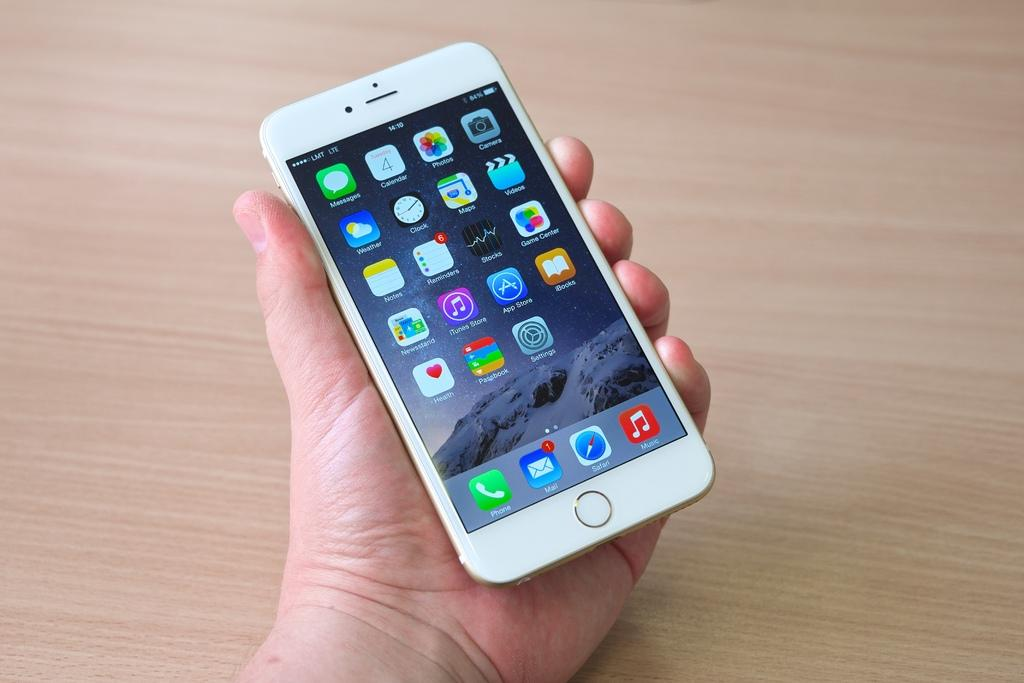<image>
Offer a succinct explanation of the picture presented. A white phone with applications on the screen including "Music", "Passbook", and "Weather". 